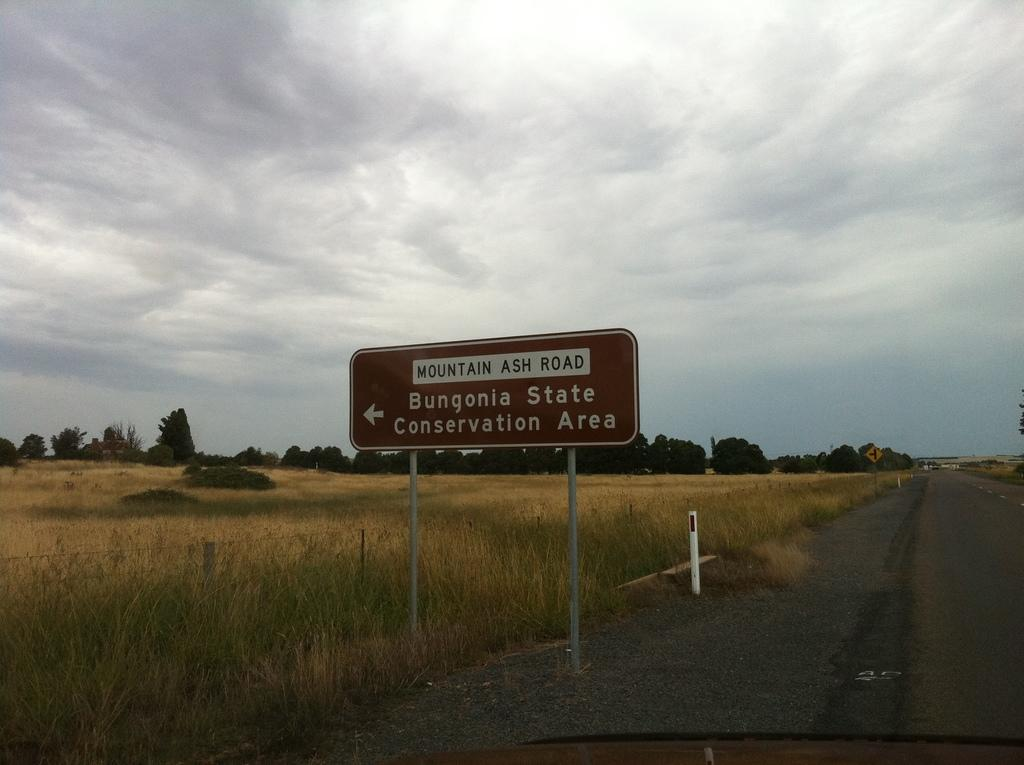Provide a one-sentence caption for the provided image. A road with a brown sign that is indicating where Bungonia State Conservation Area is. 